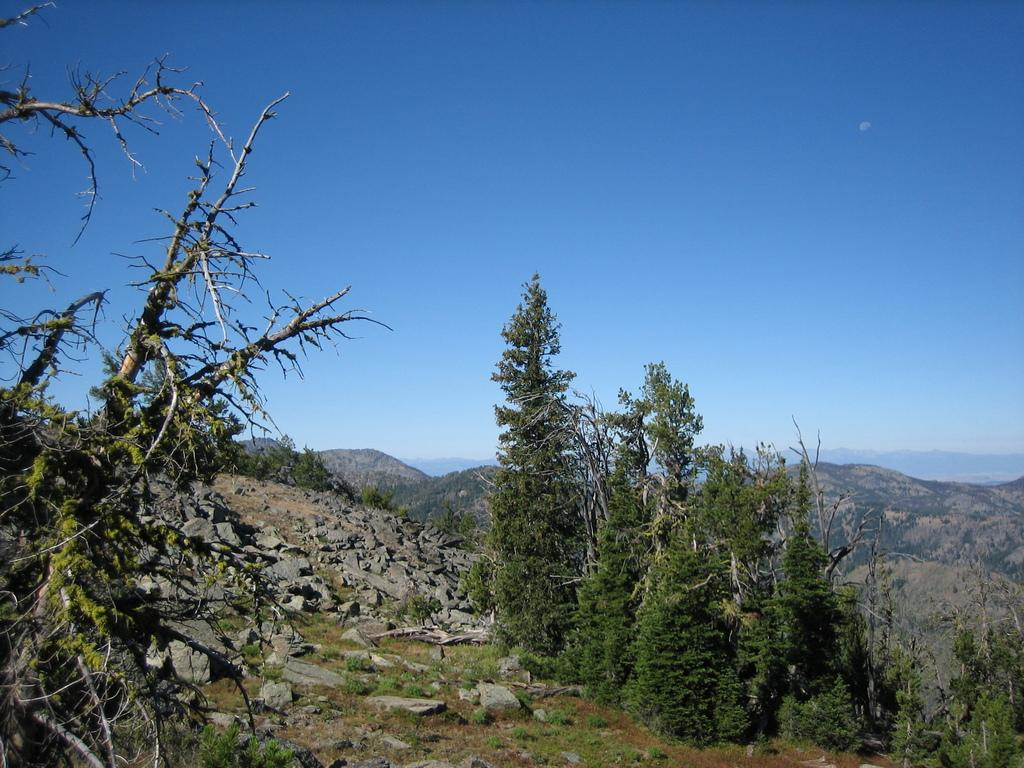What type of vegetation is present in the image? There are trees in the image. What is the color of the trees? The trees are green in color. What can be seen in the background of the image? There are stones and mountains visible in the background of the image. What is the color of the sky in the image? The sky is blue in color. What type of bell can be heard ringing in the image? There is no bell present in the image, and therefore no sound can be heard. 